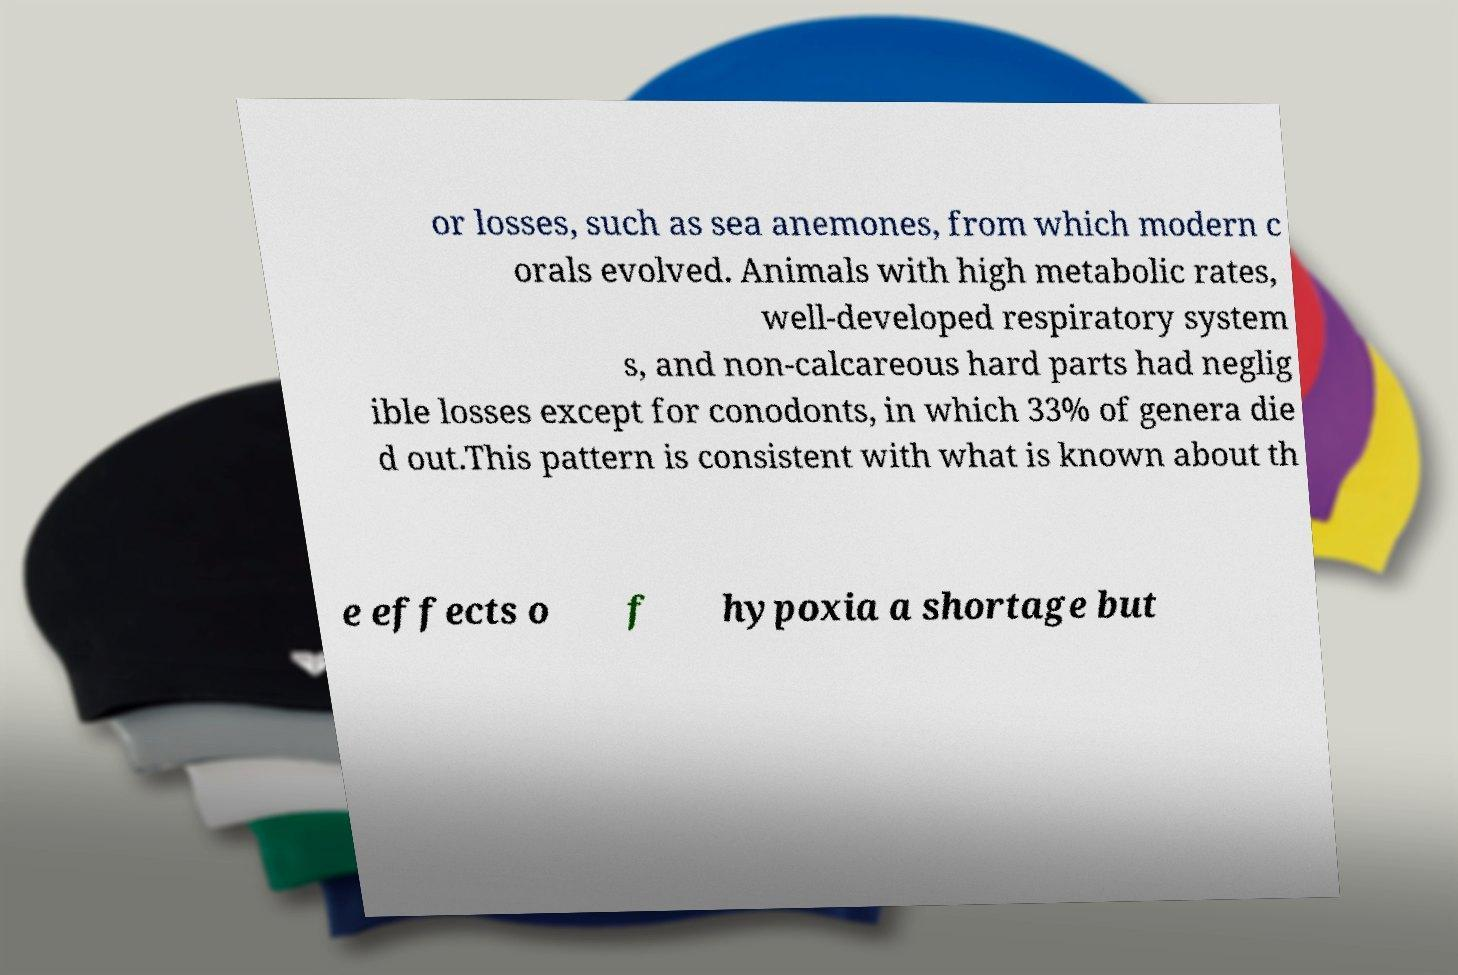Can you read and provide the text displayed in the image?This photo seems to have some interesting text. Can you extract and type it out for me? or losses, such as sea anemones, from which modern c orals evolved. Animals with high metabolic rates, well-developed respiratory system s, and non-calcareous hard parts had neglig ible losses except for conodonts, in which 33% of genera die d out.This pattern is consistent with what is known about th e effects o f hypoxia a shortage but 